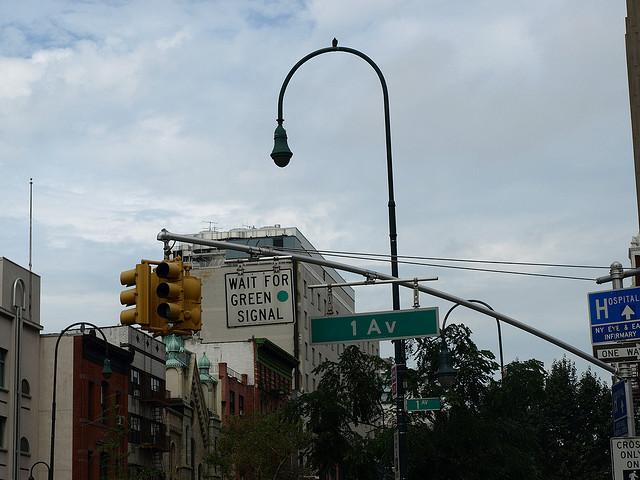How many birds are there?
Quick response, please. 0. What's the name of the cross street to the left?
Concise answer only. 1 av. Is the traffic light suspended above something?
Answer briefly. Yes. What light can you see?
Concise answer only. Street light. Are there more than a dozen birds?
Short answer required. No. What are the lights attached to?
Keep it brief. Pole. What is the blue sign directing people to?
Be succinct. Hospital. What does the sign by the traffic light say?
Be succinct. Wait for green signal. Is the sky clear?
Be succinct. No. What does the street sign say?
Keep it brief. 1 av. Why are there two sets of street lights?
Short answer required. Different directions. Are the street lights obtrusive in the windows at night?
Write a very short answer. No. 